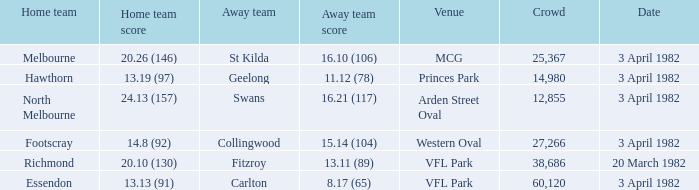Which home team played the away team of collingwood? Footscray. 